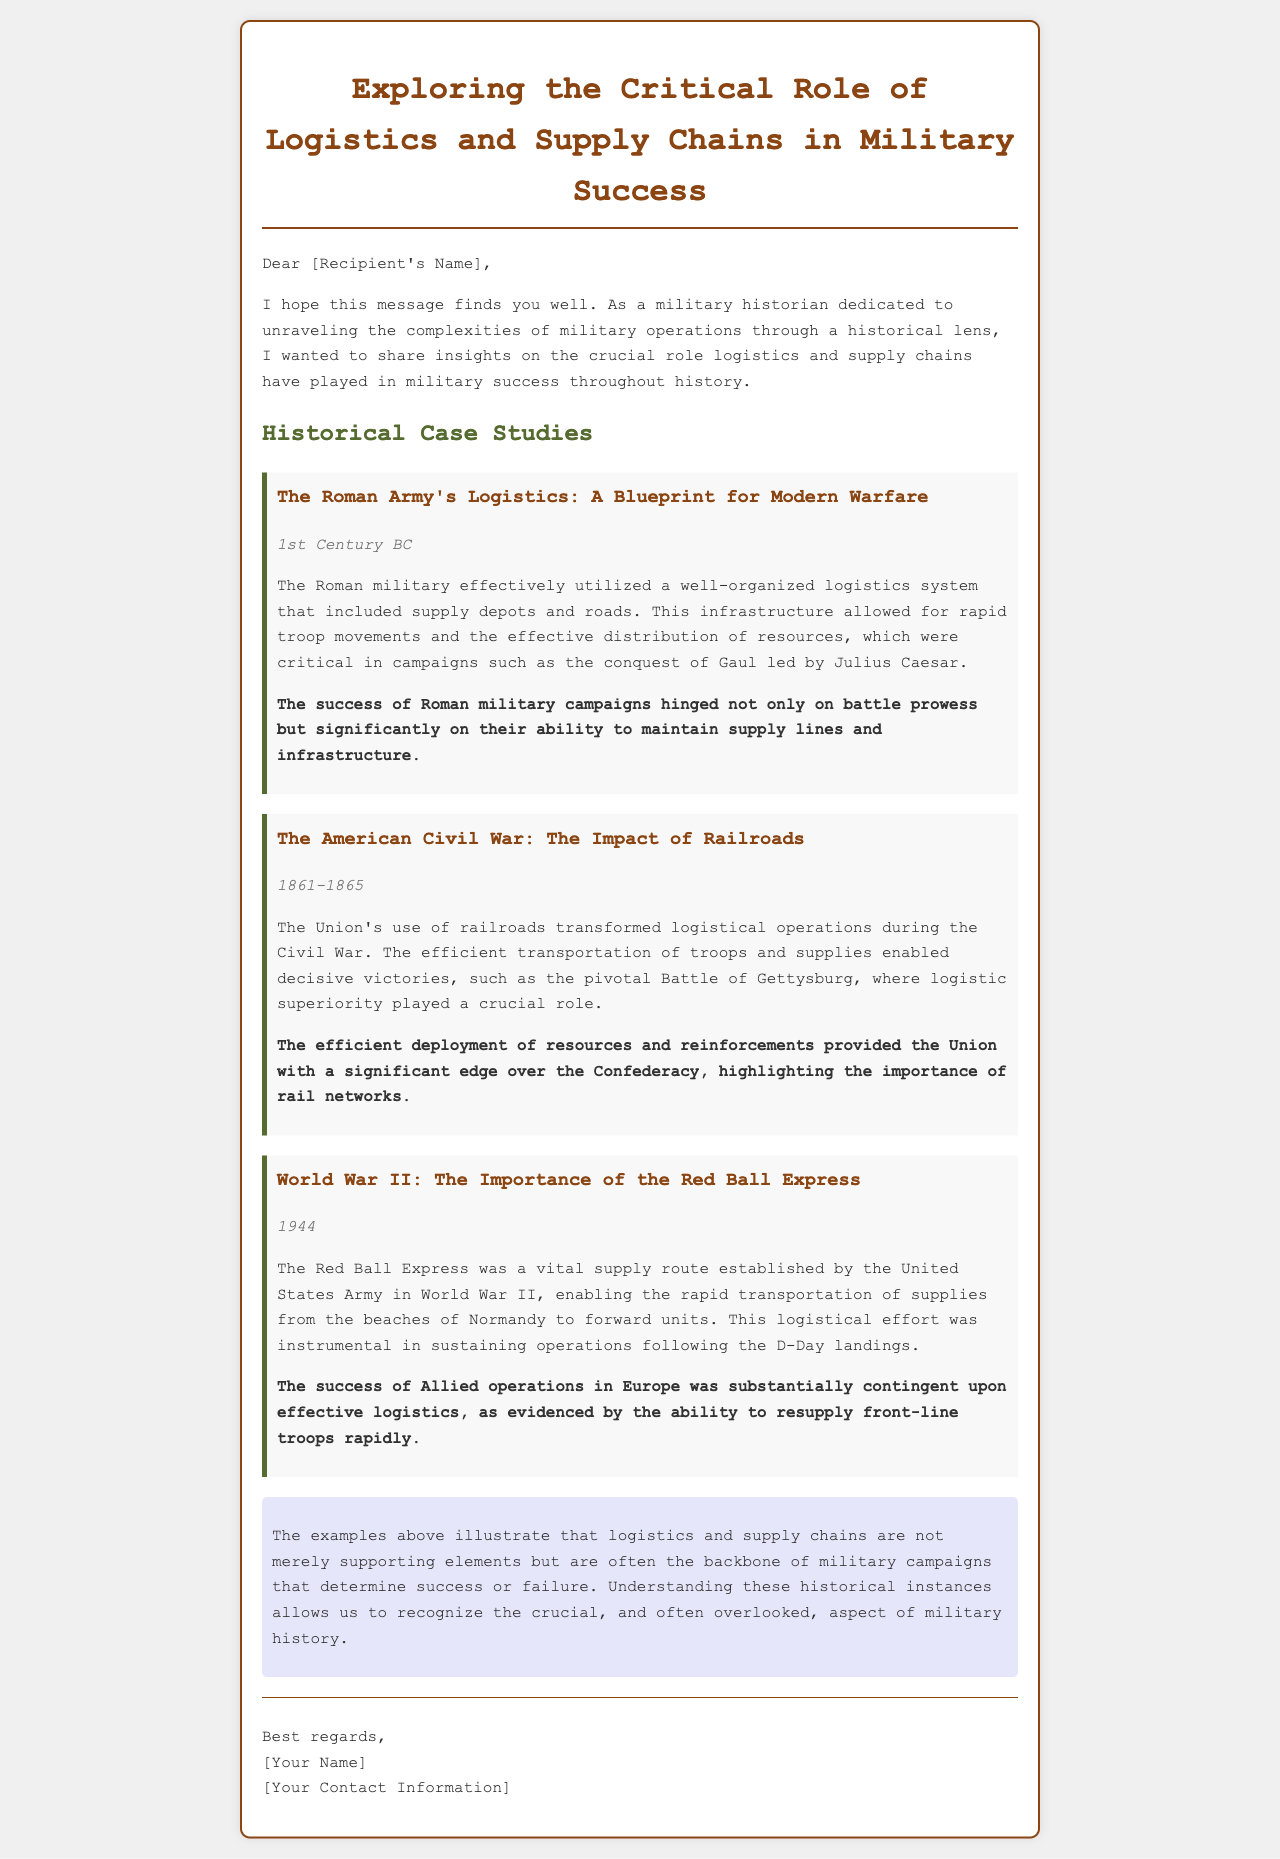What is the title of the email? The title of the email is stated at the top in a prominent header format.
Answer: Exploring the Critical Role of Logistics and Supply Chains in Military Success What century does the Roman Army's logistics case study refer to? The case study of the Roman Army specifies its duration clearly in the provided section.
Answer: 1st Century BC What war is associated with the use of railroads, according to the document? The document mentions a specific conflict where railroads played a significant role in logistics operations.
Answer: The American Civil War During which year did the Red Ball Express operate? The document notes the specific year for the case study on the Red Ball Express in World War II.
Answer: 1944 What key logistical feature contributed to the success of the Roman military campaigns? The document highlights a crucial aspect of the Roman army's operations that was vital for their campaigns.
Answer: Supply lines What battle is explicitly mentioned in the American Civil War case study? The document identifies a pivotal battle where logistics were crucial for the Union.
Answer: The Battle of Gettysburg According to the conclusion, what are logistics and supply chains often described as in military campaigns? The conclusion summarizes the importance of logistics and supply chains in relation to military campaigns.
Answer: The backbone What aspect of military history does the author find often overlooked? The conclusion implies an aspect of military operations that is frequently neglected in historical discussions.
Answer: Logistics and supply chains 